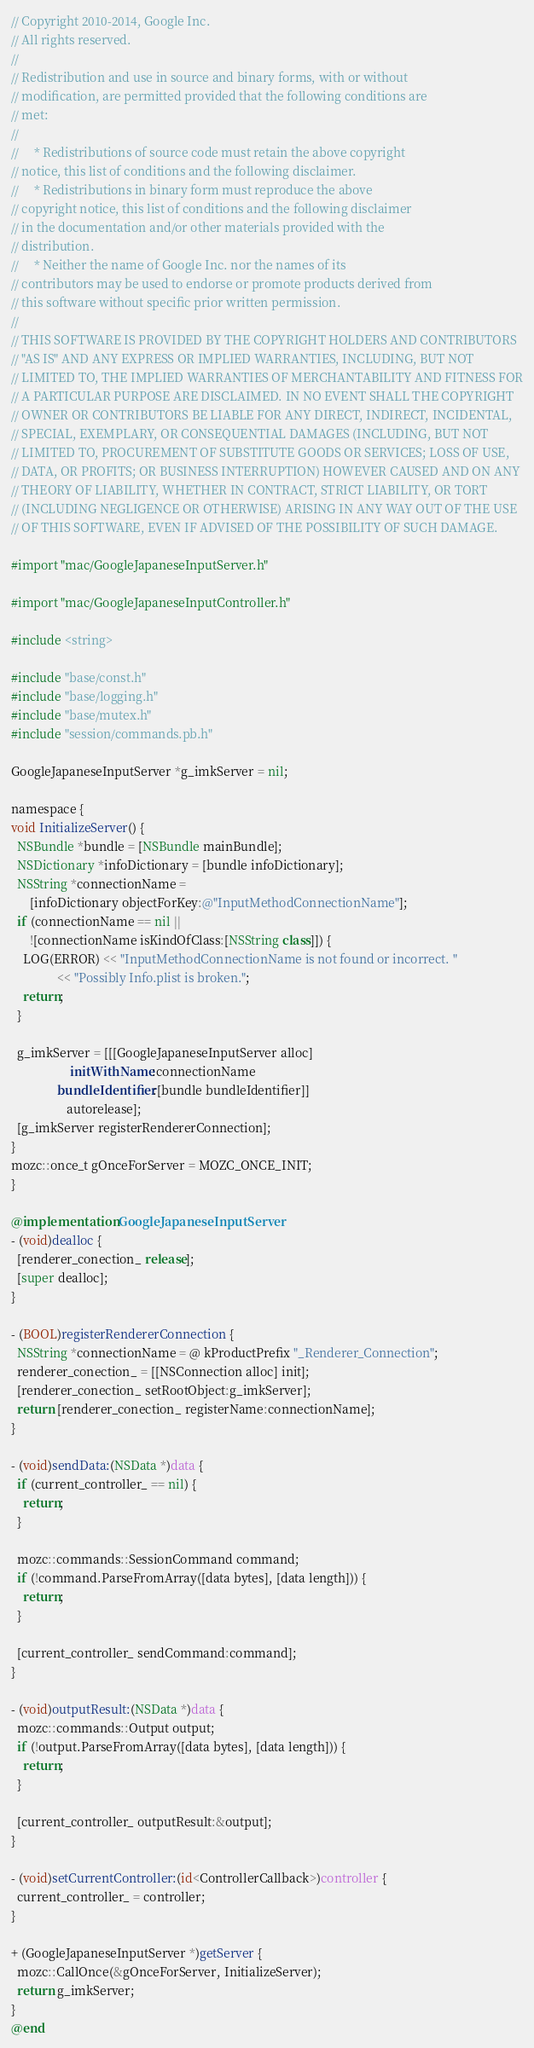Convert code to text. <code><loc_0><loc_0><loc_500><loc_500><_ObjectiveC_>// Copyright 2010-2014, Google Inc.
// All rights reserved.
//
// Redistribution and use in source and binary forms, with or without
// modification, are permitted provided that the following conditions are
// met:
//
//     * Redistributions of source code must retain the above copyright
// notice, this list of conditions and the following disclaimer.
//     * Redistributions in binary form must reproduce the above
// copyright notice, this list of conditions and the following disclaimer
// in the documentation and/or other materials provided with the
// distribution.
//     * Neither the name of Google Inc. nor the names of its
// contributors may be used to endorse or promote products derived from
// this software without specific prior written permission.
//
// THIS SOFTWARE IS PROVIDED BY THE COPYRIGHT HOLDERS AND CONTRIBUTORS
// "AS IS" AND ANY EXPRESS OR IMPLIED WARRANTIES, INCLUDING, BUT NOT
// LIMITED TO, THE IMPLIED WARRANTIES OF MERCHANTABILITY AND FITNESS FOR
// A PARTICULAR PURPOSE ARE DISCLAIMED. IN NO EVENT SHALL THE COPYRIGHT
// OWNER OR CONTRIBUTORS BE LIABLE FOR ANY DIRECT, INDIRECT, INCIDENTAL,
// SPECIAL, EXEMPLARY, OR CONSEQUENTIAL DAMAGES (INCLUDING, BUT NOT
// LIMITED TO, PROCUREMENT OF SUBSTITUTE GOODS OR SERVICES; LOSS OF USE,
// DATA, OR PROFITS; OR BUSINESS INTERRUPTION) HOWEVER CAUSED AND ON ANY
// THEORY OF LIABILITY, WHETHER IN CONTRACT, STRICT LIABILITY, OR TORT
// (INCLUDING NEGLIGENCE OR OTHERWISE) ARISING IN ANY WAY OUT OF THE USE
// OF THIS SOFTWARE, EVEN IF ADVISED OF THE POSSIBILITY OF SUCH DAMAGE.

#import "mac/GoogleJapaneseInputServer.h"

#import "mac/GoogleJapaneseInputController.h"

#include <string>

#include "base/const.h"
#include "base/logging.h"
#include "base/mutex.h"
#include "session/commands.pb.h"

GoogleJapaneseInputServer *g_imkServer = nil;

namespace {
void InitializeServer() {
  NSBundle *bundle = [NSBundle mainBundle];
  NSDictionary *infoDictionary = [bundle infoDictionary];
  NSString *connectionName =
      [infoDictionary objectForKey:@"InputMethodConnectionName"];
  if (connectionName == nil ||
      ![connectionName isKindOfClass:[NSString class]]) {
    LOG(ERROR) << "InputMethodConnectionName is not found or incorrect. "
               << "Possibly Info.plist is broken.";
    return;
  }

  g_imkServer = [[[GoogleJapaneseInputServer alloc]
                   initWithName:connectionName
               bundleIdentifier:[bundle bundleIdentifier]]
                  autorelease];
  [g_imkServer registerRendererConnection];
}
mozc::once_t gOnceForServer = MOZC_ONCE_INIT;
}

@implementation GoogleJapaneseInputServer
- (void)dealloc {
  [renderer_conection_ release];
  [super dealloc];
}

- (BOOL)registerRendererConnection {
  NSString *connectionName = @ kProductPrefix "_Renderer_Connection";
  renderer_conection_ = [[NSConnection alloc] init];
  [renderer_conection_ setRootObject:g_imkServer];
  return [renderer_conection_ registerName:connectionName];
}

- (void)sendData:(NSData *)data {
  if (current_controller_ == nil) {
    return;
  }

  mozc::commands::SessionCommand command;
  if (!command.ParseFromArray([data bytes], [data length])) {
    return;
  }

  [current_controller_ sendCommand:command];
}

- (void)outputResult:(NSData *)data {
  mozc::commands::Output output;
  if (!output.ParseFromArray([data bytes], [data length])) {
    return;
  }

  [current_controller_ outputResult:&output];
}

- (void)setCurrentController:(id<ControllerCallback>)controller {
  current_controller_ = controller;
}

+ (GoogleJapaneseInputServer *)getServer {
  mozc::CallOnce(&gOnceForServer, InitializeServer);
  return g_imkServer;
}
@end
</code> 